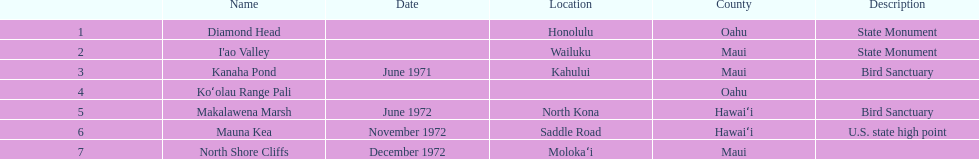In the chart, which county appears most frequently? Maui. 